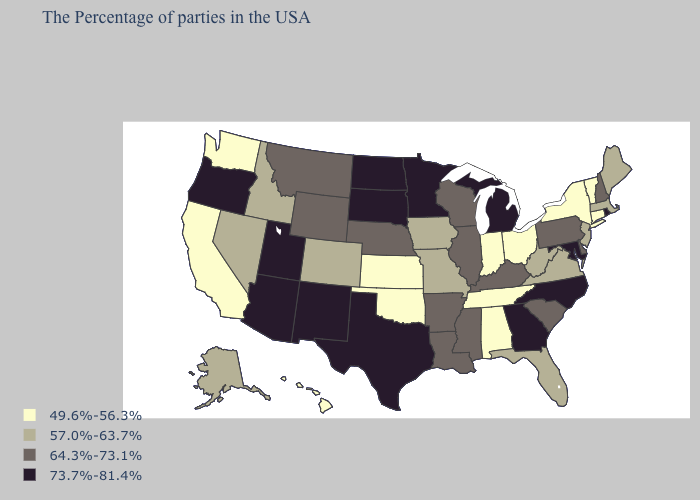Name the states that have a value in the range 49.6%-56.3%?
Quick response, please. Vermont, Connecticut, New York, Ohio, Indiana, Alabama, Tennessee, Kansas, Oklahoma, California, Washington, Hawaii. Does New Jersey have the highest value in the Northeast?
Write a very short answer. No. Which states have the highest value in the USA?
Answer briefly. Rhode Island, Maryland, North Carolina, Georgia, Michigan, Minnesota, Texas, South Dakota, North Dakota, New Mexico, Utah, Arizona, Oregon. Does Oregon have a higher value than West Virginia?
Keep it brief. Yes. Is the legend a continuous bar?
Give a very brief answer. No. What is the value of West Virginia?
Concise answer only. 57.0%-63.7%. Which states have the highest value in the USA?
Be succinct. Rhode Island, Maryland, North Carolina, Georgia, Michigan, Minnesota, Texas, South Dakota, North Dakota, New Mexico, Utah, Arizona, Oregon. What is the value of Colorado?
Give a very brief answer. 57.0%-63.7%. Name the states that have a value in the range 64.3%-73.1%?
Give a very brief answer. New Hampshire, Delaware, Pennsylvania, South Carolina, Kentucky, Wisconsin, Illinois, Mississippi, Louisiana, Arkansas, Nebraska, Wyoming, Montana. What is the value of New Jersey?
Give a very brief answer. 57.0%-63.7%. Which states have the highest value in the USA?
Quick response, please. Rhode Island, Maryland, North Carolina, Georgia, Michigan, Minnesota, Texas, South Dakota, North Dakota, New Mexico, Utah, Arizona, Oregon. Which states have the lowest value in the MidWest?
Short answer required. Ohio, Indiana, Kansas. How many symbols are there in the legend?
Concise answer only. 4. What is the lowest value in the MidWest?
Be succinct. 49.6%-56.3%. Among the states that border Florida , which have the lowest value?
Be succinct. Alabama. 